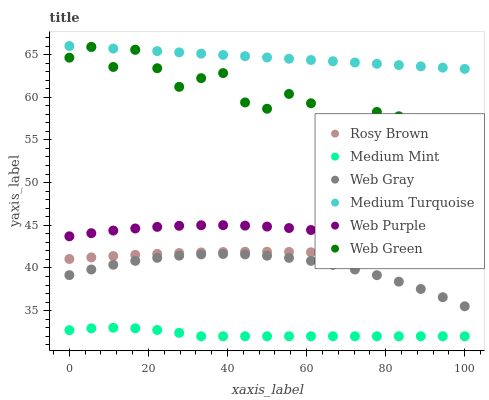Does Medium Mint have the minimum area under the curve?
Answer yes or no. Yes. Does Medium Turquoise have the maximum area under the curve?
Answer yes or no. Yes. Does Web Gray have the minimum area under the curve?
Answer yes or no. No. Does Web Gray have the maximum area under the curve?
Answer yes or no. No. Is Medium Turquoise the smoothest?
Answer yes or no. Yes. Is Web Green the roughest?
Answer yes or no. Yes. Is Web Gray the smoothest?
Answer yes or no. No. Is Web Gray the roughest?
Answer yes or no. No. Does Medium Mint have the lowest value?
Answer yes or no. Yes. Does Web Gray have the lowest value?
Answer yes or no. No. Does Medium Turquoise have the highest value?
Answer yes or no. Yes. Does Web Gray have the highest value?
Answer yes or no. No. Is Web Purple less than Medium Turquoise?
Answer yes or no. Yes. Is Web Gray greater than Medium Mint?
Answer yes or no. Yes. Does Web Green intersect Medium Turquoise?
Answer yes or no. Yes. Is Web Green less than Medium Turquoise?
Answer yes or no. No. Is Web Green greater than Medium Turquoise?
Answer yes or no. No. Does Web Purple intersect Medium Turquoise?
Answer yes or no. No. 